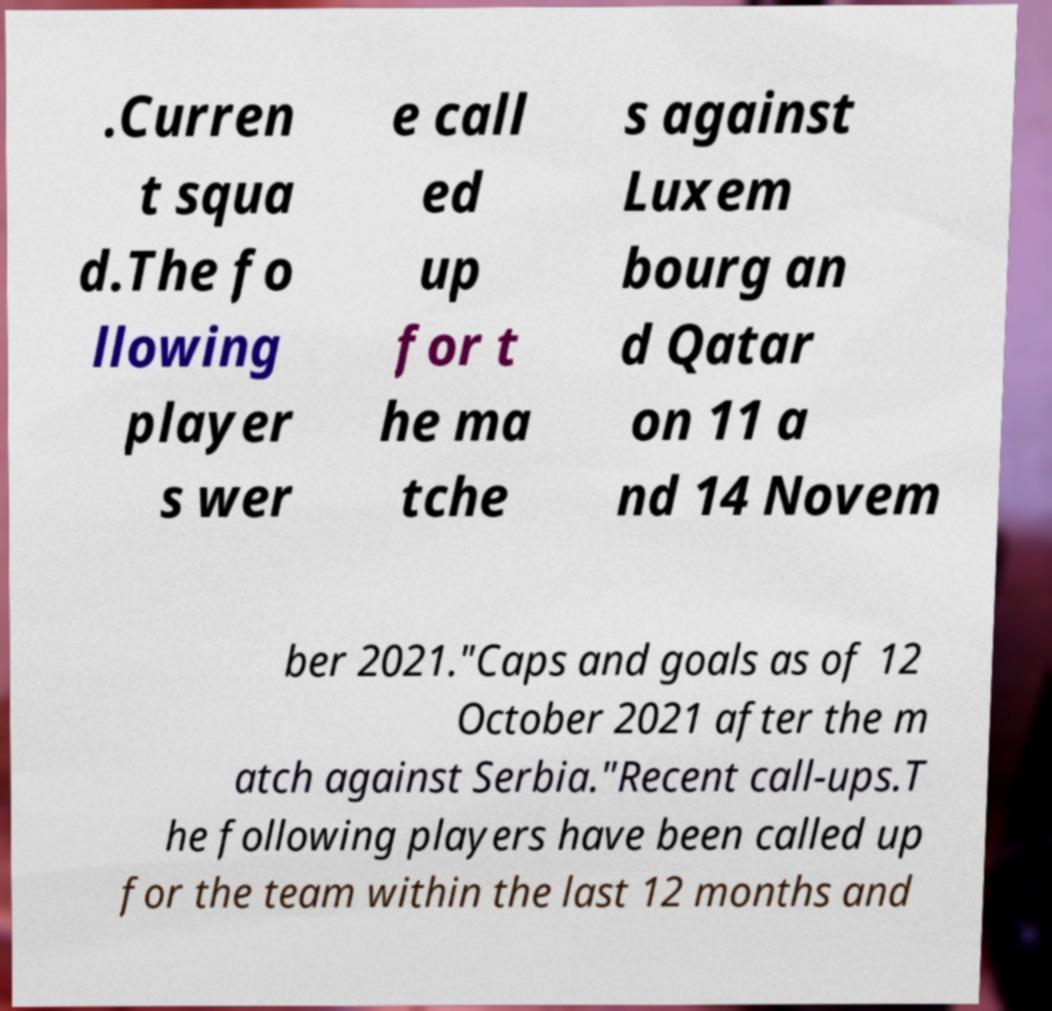Could you assist in decoding the text presented in this image and type it out clearly? .Curren t squa d.The fo llowing player s wer e call ed up for t he ma tche s against Luxem bourg an d Qatar on 11 a nd 14 Novem ber 2021."Caps and goals as of 12 October 2021 after the m atch against Serbia."Recent call-ups.T he following players have been called up for the team within the last 12 months and 